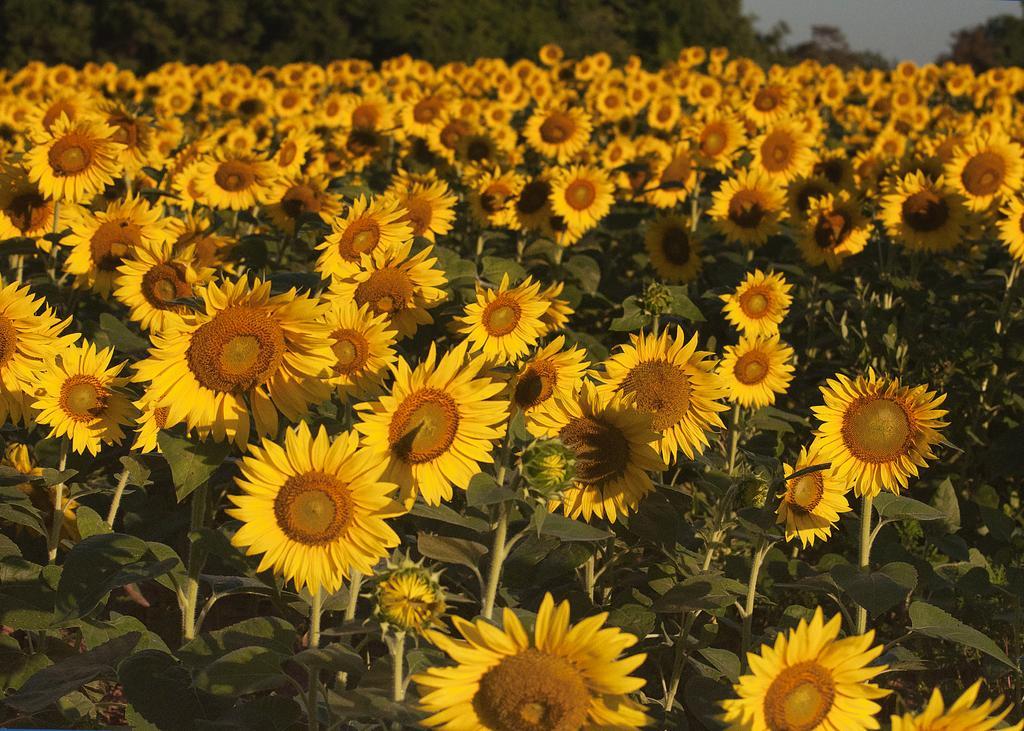In one or two sentences, can you explain what this image depicts? In this image I can see few sunflowers and few green leaves. Flowers are in yellow color. Back I can see few trees. 